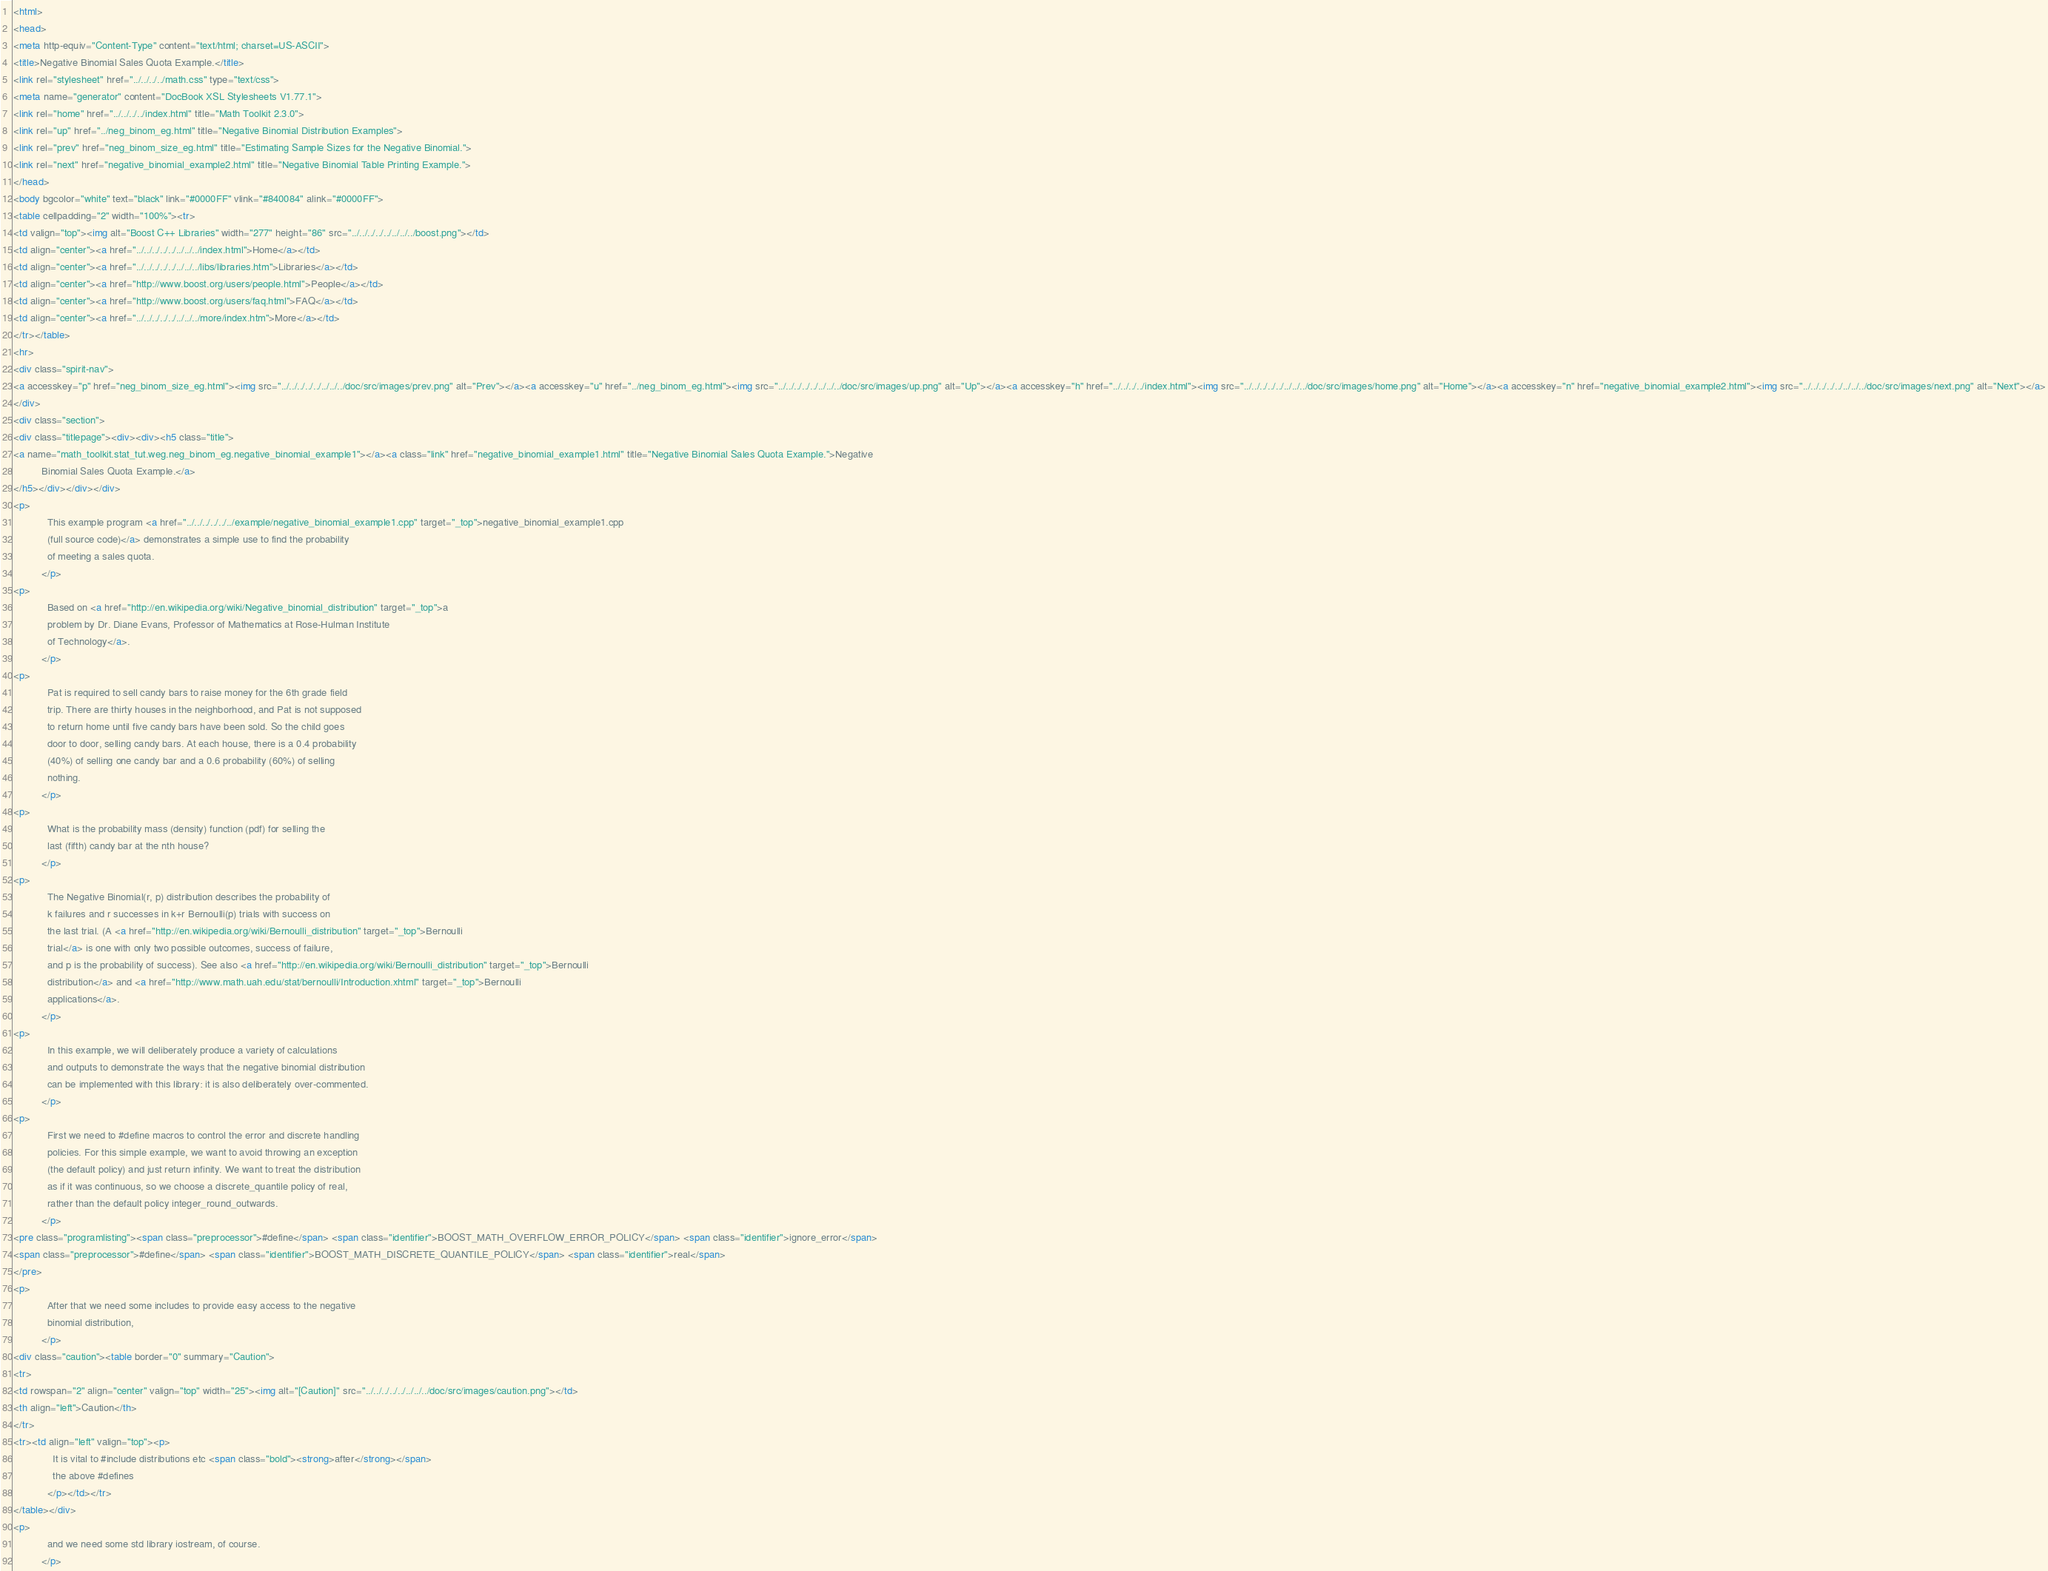Convert code to text. <code><loc_0><loc_0><loc_500><loc_500><_HTML_><html>
<head>
<meta http-equiv="Content-Type" content="text/html; charset=US-ASCII">
<title>Negative Binomial Sales Quota Example.</title>
<link rel="stylesheet" href="../../../../math.css" type="text/css">
<meta name="generator" content="DocBook XSL Stylesheets V1.77.1">
<link rel="home" href="../../../../index.html" title="Math Toolkit 2.3.0">
<link rel="up" href="../neg_binom_eg.html" title="Negative Binomial Distribution Examples">
<link rel="prev" href="neg_binom_size_eg.html" title="Estimating Sample Sizes for the Negative Binomial.">
<link rel="next" href="negative_binomial_example2.html" title="Negative Binomial Table Printing Example.">
</head>
<body bgcolor="white" text="black" link="#0000FF" vlink="#840084" alink="#0000FF">
<table cellpadding="2" width="100%"><tr>
<td valign="top"><img alt="Boost C++ Libraries" width="277" height="86" src="../../../../../../../../boost.png"></td>
<td align="center"><a href="../../../../../../../../index.html">Home</a></td>
<td align="center"><a href="../../../../../../../../libs/libraries.htm">Libraries</a></td>
<td align="center"><a href="http://www.boost.org/users/people.html">People</a></td>
<td align="center"><a href="http://www.boost.org/users/faq.html">FAQ</a></td>
<td align="center"><a href="../../../../../../../../more/index.htm">More</a></td>
</tr></table>
<hr>
<div class="spirit-nav">
<a accesskey="p" href="neg_binom_size_eg.html"><img src="../../../../../../../../doc/src/images/prev.png" alt="Prev"></a><a accesskey="u" href="../neg_binom_eg.html"><img src="../../../../../../../../doc/src/images/up.png" alt="Up"></a><a accesskey="h" href="../../../../index.html"><img src="../../../../../../../../doc/src/images/home.png" alt="Home"></a><a accesskey="n" href="negative_binomial_example2.html"><img src="../../../../../../../../doc/src/images/next.png" alt="Next"></a>
</div>
<div class="section">
<div class="titlepage"><div><div><h5 class="title">
<a name="math_toolkit.stat_tut.weg.neg_binom_eg.negative_binomial_example1"></a><a class="link" href="negative_binomial_example1.html" title="Negative Binomial Sales Quota Example.">Negative
          Binomial Sales Quota Example.</a>
</h5></div></div></div>
<p>
            This example program <a href="../../../../../../example/negative_binomial_example1.cpp" target="_top">negative_binomial_example1.cpp
            (full source code)</a> demonstrates a simple use to find the probability
            of meeting a sales quota.
          </p>
<p>
            Based on <a href="http://en.wikipedia.org/wiki/Negative_binomial_distribution" target="_top">a
            problem by Dr. Diane Evans, Professor of Mathematics at Rose-Hulman Institute
            of Technology</a>.
          </p>
<p>
            Pat is required to sell candy bars to raise money for the 6th grade field
            trip. There are thirty houses in the neighborhood, and Pat is not supposed
            to return home until five candy bars have been sold. So the child goes
            door to door, selling candy bars. At each house, there is a 0.4 probability
            (40%) of selling one candy bar and a 0.6 probability (60%) of selling
            nothing.
          </p>
<p>
            What is the probability mass (density) function (pdf) for selling the
            last (fifth) candy bar at the nth house?
          </p>
<p>
            The Negative Binomial(r, p) distribution describes the probability of
            k failures and r successes in k+r Bernoulli(p) trials with success on
            the last trial. (A <a href="http://en.wikipedia.org/wiki/Bernoulli_distribution" target="_top">Bernoulli
            trial</a> is one with only two possible outcomes, success of failure,
            and p is the probability of success). See also <a href="http://en.wikipedia.org/wiki/Bernoulli_distribution" target="_top">Bernoulli
            distribution</a> and <a href="http://www.math.uah.edu/stat/bernoulli/Introduction.xhtml" target="_top">Bernoulli
            applications</a>.
          </p>
<p>
            In this example, we will deliberately produce a variety of calculations
            and outputs to demonstrate the ways that the negative binomial distribution
            can be implemented with this library: it is also deliberately over-commented.
          </p>
<p>
            First we need to #define macros to control the error and discrete handling
            policies. For this simple example, we want to avoid throwing an exception
            (the default policy) and just return infinity. We want to treat the distribution
            as if it was continuous, so we choose a discrete_quantile policy of real,
            rather than the default policy integer_round_outwards.
          </p>
<pre class="programlisting"><span class="preprocessor">#define</span> <span class="identifier">BOOST_MATH_OVERFLOW_ERROR_POLICY</span> <span class="identifier">ignore_error</span>
<span class="preprocessor">#define</span> <span class="identifier">BOOST_MATH_DISCRETE_QUANTILE_POLICY</span> <span class="identifier">real</span>
</pre>
<p>
            After that we need some includes to provide easy access to the negative
            binomial distribution,
          </p>
<div class="caution"><table border="0" summary="Caution">
<tr>
<td rowspan="2" align="center" valign="top" width="25"><img alt="[Caution]" src="../../../../../../../../doc/src/images/caution.png"></td>
<th align="left">Caution</th>
</tr>
<tr><td align="left" valign="top"><p>
              It is vital to #include distributions etc <span class="bold"><strong>after</strong></span>
              the above #defines
            </p></td></tr>
</table></div>
<p>
            and we need some std library iostream, of course.
          </p></code> 